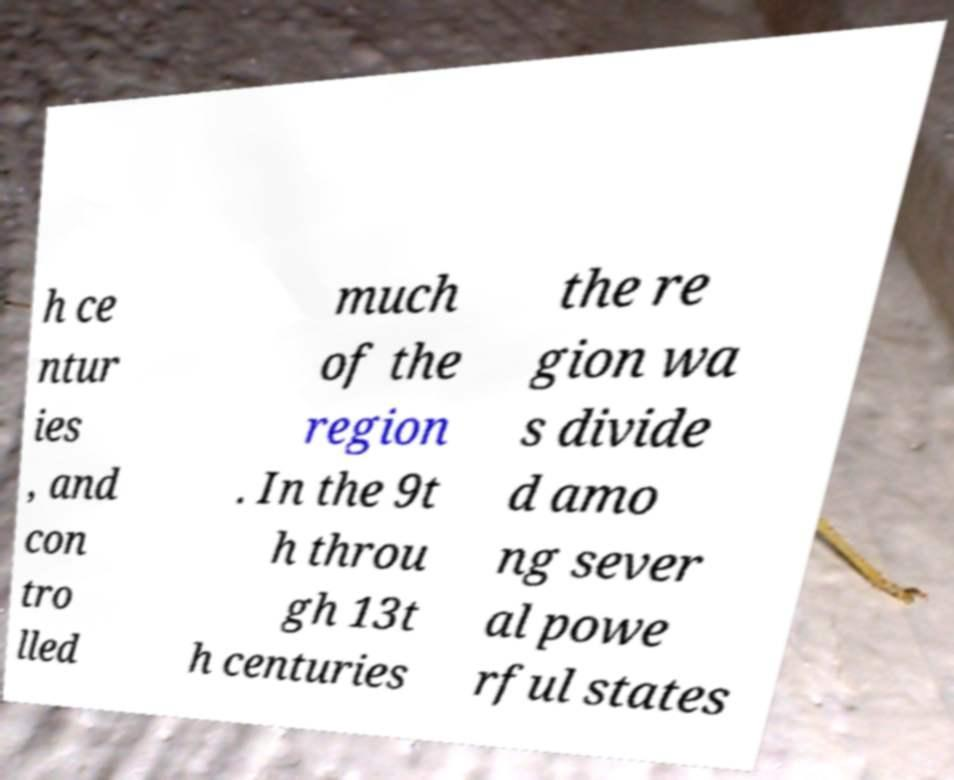What messages or text are displayed in this image? I need them in a readable, typed format. h ce ntur ies , and con tro lled much of the region . In the 9t h throu gh 13t h centuries the re gion wa s divide d amo ng sever al powe rful states 